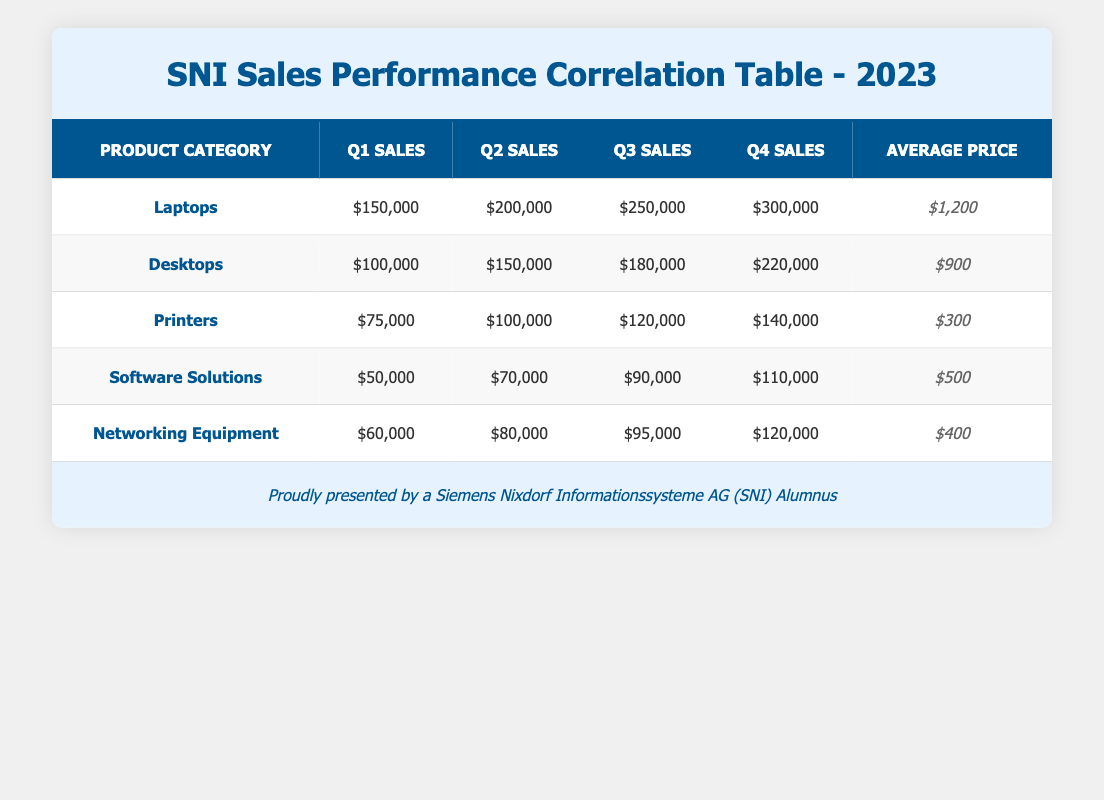What was the total sales for Laptops in 2023? To find the total sales for Laptops, we need to sum the quarterly sales: Q1_sales (150,000) + Q2_sales (200,000) + Q3_sales (250,000) + Q4_sales (300,000) = 150,000 + 200,000 + 250,000 + 300,000 = 900,000.
Answer: 900,000 Which product category had the highest average price? Looking at the average price column, Laptops has the highest average price at 1,200, compared to other categories: Desktops (900), Printers (300), Software Solutions (500), Networking Equipment (400).
Answer: Laptops What was the sales growth from Q1 to Q4 for Networking Equipment? To calculate the growth, subtract Q1_sales (60,000) from Q4_sales (120,000): 120,000 - 60,000 = 60,000. The sales growth from Q1 to Q4 is 60,000.
Answer: 60,000 Did Software Solutions have more sales in Q3 than Printers in Q1? By checking the Q3 sales for Software Solutions (90,000) and the Q1 sales for Printers (75,000), we find that 90,000 is greater than 75,000, which confirms the statement.
Answer: Yes What is the average sales for all product categories in Q2? To find the average Q2 sales, sum the Q2 sales for all categories: 200,000 (Laptops) + 150,000 (Desktops) + 100,000 (Printers) + 70,000 (Software Solutions) + 80,000 (Networking Equipment) = 600,000. Divide by the number of categories (5) gives an average of 600,000 / 5 = 120,000.
Answer: 120,000 Which product category had the lowest total sales in 2023? Total sales for each category are calculated as follows: Laptops (900,000), Desktops (650,000), Printers (425,000), Software Solutions (320,000), and Networking Equipment (355,000). Comparing these, Software Solutions has the lowest total of 320,000.
Answer: Software Solutions How much more did Laptops sell than Printers in Q4? For Q4, Laptops sold 300,000 while Printers sold 140,000. The difference is calculated by subtracting Printers sales from Laptops sales: 300,000 - 140,000 = 160,000.
Answer: 160,000 Is the average price of Desktops lower than that of Networking Equipment? The average price for Desktops is 900 while for Networking Equipment it is 400. Since 900 is greater than 400, the statement is false.
Answer: No What was the percentage increase in sales from Q1 to Q4 for Desktops? To calculate the percentage increase, we need to find the change in sales: Q4_sales (220,000) - Q1_sales (100,000) = 120,000. Then divide the change by the original Q1 sales: 120,000 / 100,000 = 1.2. To convert it to a percentage, multiply by 100, resulting in a percentage increase of 120%.
Answer: 120% 